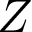<formula> <loc_0><loc_0><loc_500><loc_500>Z</formula> 